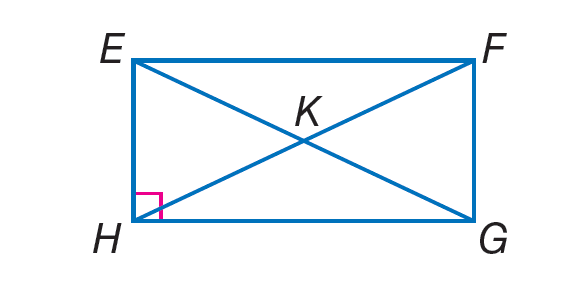Answer the mathemtical geometry problem and directly provide the correct option letter.
Question: Quadrilateral E F G H is a rectangle. If m \angle F E G = 57, find m \angle G E H.
Choices: A: 13 B: 20 C: 33 D: 57 C 